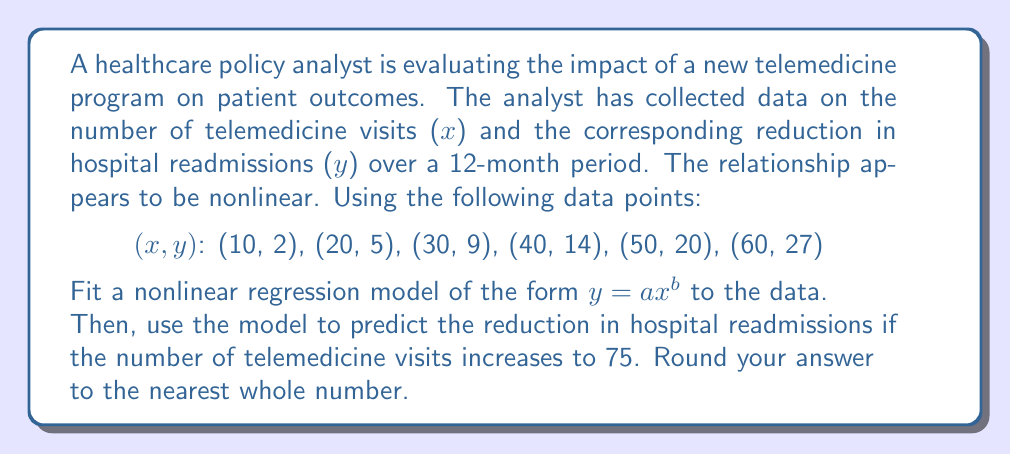Provide a solution to this math problem. To solve this problem, we'll follow these steps:

1) First, we need to linearize the nonlinear model $y = ax^b$ by taking logarithms of both sides:

   $\log(y) = \log(a) + b\log(x)$

2) Let $Y = \log(y)$, $A = \log(a)$, and $X = \log(x)$. Now we have a linear equation:

   $Y = A + bX$

3) We can use linear regression techniques on the transformed data. Let's create a table of transformed data:

   $X = \log(x)$ | $Y = \log(y)$
   2.3026        | 0.6931
   2.9957        | 1.6094
   3.4012        | 2.1972
   3.6889        | 2.6391
   3.9120        | 2.9957
   4.0943        | 3.2958

4) Now we can use the formulas for linear regression:

   $b = \frac{n\sum XY - \sum X \sum Y}{n\sum X^2 - (\sum X)^2}$

   $A = \bar{Y} - b\bar{X}$

5) Calculating the sums (you would use a calculator for this):

   $\sum X = 20.3947$, $\sum Y = 13.4303$, $\sum XY = 46.7590$, $\sum X^2 = 70.7744$
   $n = 6$, $\bar{X} = 3.3991$, $\bar{Y} = 2.2384$

6) Plugging into the formulas:

   $b = \frac{6(46.7590) - (20.3947)(13.4303)}{6(70.7744) - (20.3947)^2} = 1.5093$

   $A = 2.2384 - 1.5093(3.3991) = -2.8907$

7) Now we have $Y = -2.8907 + 1.5093X$. Transforming back:

   $\log(y) = -2.8907 + 1.5093\log(x)$

   $y = e^{-2.8907}x^{1.5093} = 0.0556x^{1.5093}$

8) To predict for x = 75:

   $y = 0.0556(75)^{1.5093} = 35.6862$

9) Rounding to the nearest whole number: 36
Answer: 36 